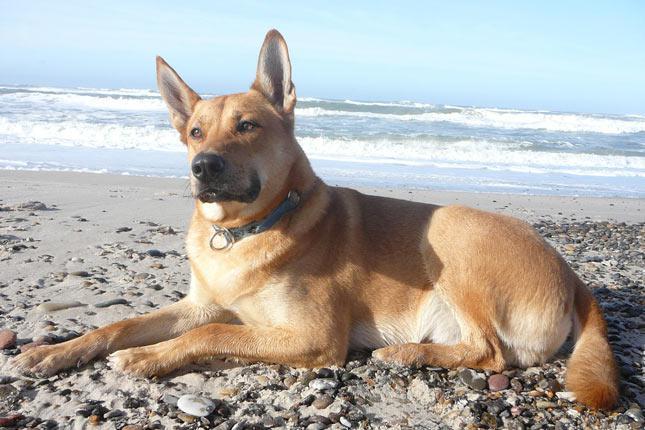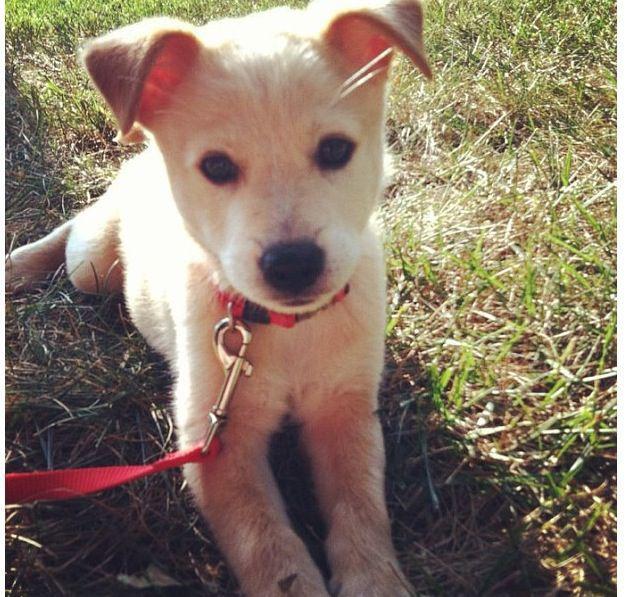The first image is the image on the left, the second image is the image on the right. Examine the images to the left and right. Is the description "Two dingo pups are overlapping in the left image, with the dingo pup in front facing the camera." accurate? Answer yes or no. No. The first image is the image on the left, the second image is the image on the right. For the images displayed, is the sentence "Every photo shows exactly one dog and all dogs are photographed outside, but the dog on the right has a visible leash attached to its collar." factually correct? Answer yes or no. Yes. 